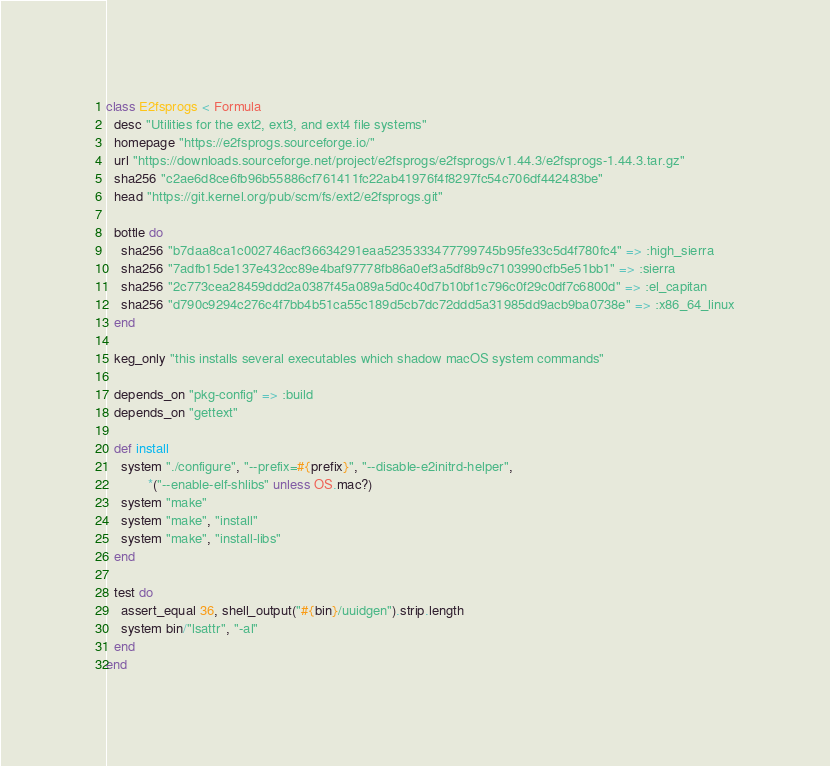<code> <loc_0><loc_0><loc_500><loc_500><_Ruby_>class E2fsprogs < Formula
  desc "Utilities for the ext2, ext3, and ext4 file systems"
  homepage "https://e2fsprogs.sourceforge.io/"
  url "https://downloads.sourceforge.net/project/e2fsprogs/e2fsprogs/v1.44.3/e2fsprogs-1.44.3.tar.gz"
  sha256 "c2ae6d8ce6fb96b55886cf761411fc22ab41976f4f8297fc54c706df442483be"
  head "https://git.kernel.org/pub/scm/fs/ext2/e2fsprogs.git"

  bottle do
    sha256 "b7daa8ca1c002746acf36634291eaa5235333477799745b95fe33c5d4f780fc4" => :high_sierra
    sha256 "7adfb15de137e432cc89e4baf97778fb86a0ef3a5df8b9c7103990cfb5e51bb1" => :sierra
    sha256 "2c773cea28459ddd2a0387f45a089a5d0c40d7b10bf1c796c0f29c0df7c6800d" => :el_capitan
    sha256 "d790c9294c276c4f7bb4b51ca55c189d5cb7dc72ddd5a31985dd9acb9ba0738e" => :x86_64_linux
  end

  keg_only "this installs several executables which shadow macOS system commands"

  depends_on "pkg-config" => :build
  depends_on "gettext"

  def install
    system "./configure", "--prefix=#{prefix}", "--disable-e2initrd-helper",
           *("--enable-elf-shlibs" unless OS.mac?)
    system "make"
    system "make", "install"
    system "make", "install-libs"
  end

  test do
    assert_equal 36, shell_output("#{bin}/uuidgen").strip.length
    system bin/"lsattr", "-al"
  end
end
</code> 